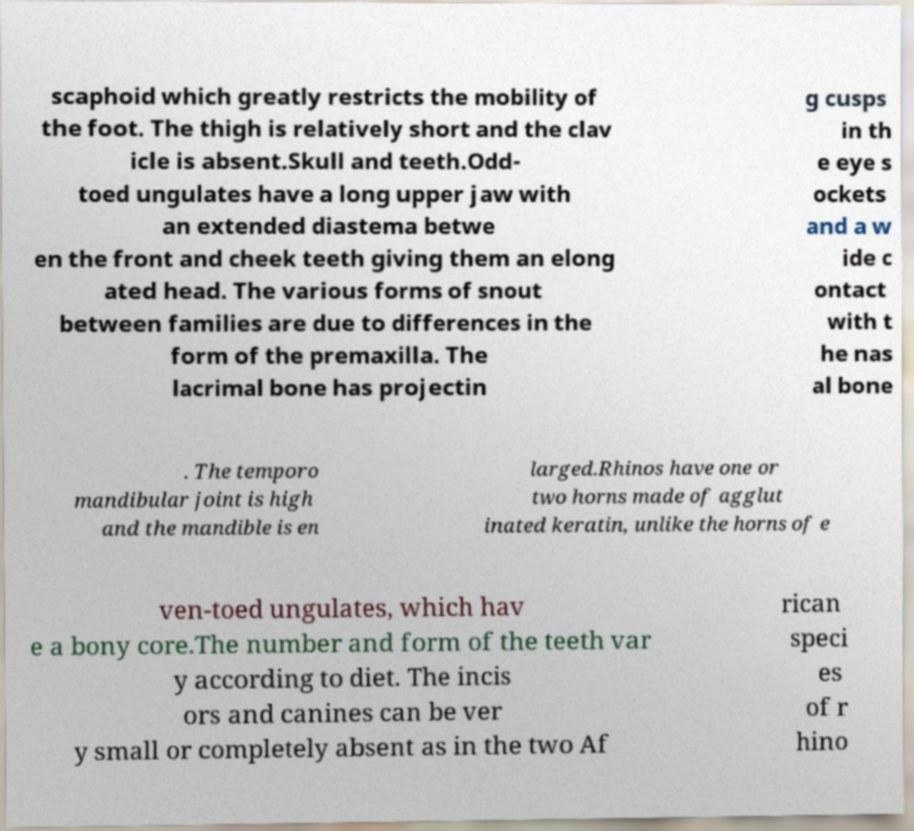Please read and relay the text visible in this image. What does it say? scaphoid which greatly restricts the mobility of the foot. The thigh is relatively short and the clav icle is absent.Skull and teeth.Odd- toed ungulates have a long upper jaw with an extended diastema betwe en the front and cheek teeth giving them an elong ated head. The various forms of snout between families are due to differences in the form of the premaxilla. The lacrimal bone has projectin g cusps in th e eye s ockets and a w ide c ontact with t he nas al bone . The temporo mandibular joint is high and the mandible is en larged.Rhinos have one or two horns made of agglut inated keratin, unlike the horns of e ven-toed ungulates, which hav e a bony core.The number and form of the teeth var y according to diet. The incis ors and canines can be ver y small or completely absent as in the two Af rican speci es of r hino 